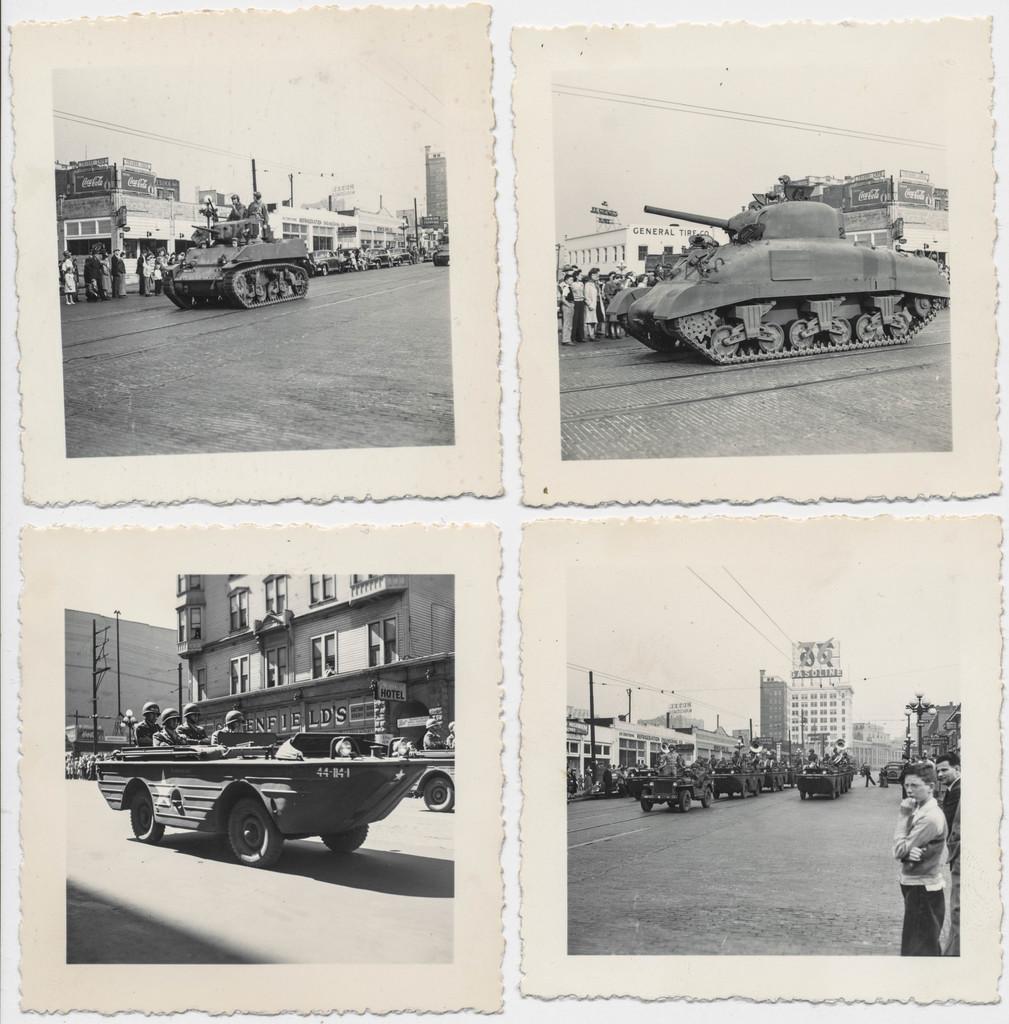In one or two sentences, can you explain what this image depicts? This picture is a collage of four images. In the first two images we can observe panzers and some people on the road. In the other two images we can observe some vehicles moving on the road. There are buildings. In the background there is a sky. All these images were black and white images. 